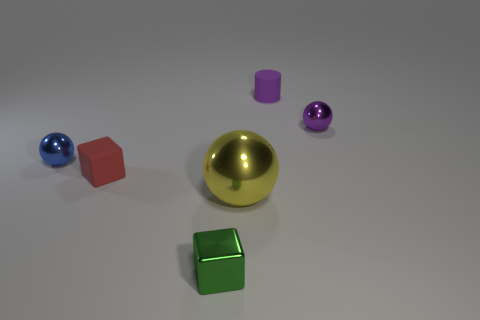What is the shape of the purple thing that is in front of the purple rubber cylinder?
Ensure brevity in your answer.  Sphere. Is there a rubber block of the same color as the large object?
Your answer should be very brief. No. There is a ball in front of the small blue metal sphere; is its size the same as the cube that is behind the small shiny block?
Keep it short and to the point. No. Is the number of metallic objects on the right side of the small red cube greater than the number of big things that are left of the matte cylinder?
Provide a succinct answer. Yes. Is there a tiny ball made of the same material as the red object?
Provide a succinct answer. No. Does the large shiny ball have the same color as the cylinder?
Keep it short and to the point. No. There is a ball that is on the right side of the red cube and on the left side of the tiny purple ball; what material is it?
Provide a short and direct response. Metal. What is the color of the big thing?
Your answer should be very brief. Yellow. How many tiny red objects are the same shape as the tiny blue metallic thing?
Keep it short and to the point. 0. Is the material of the small ball on the right side of the tiny blue shiny sphere the same as the small cube that is left of the tiny shiny block?
Offer a very short reply. No. 